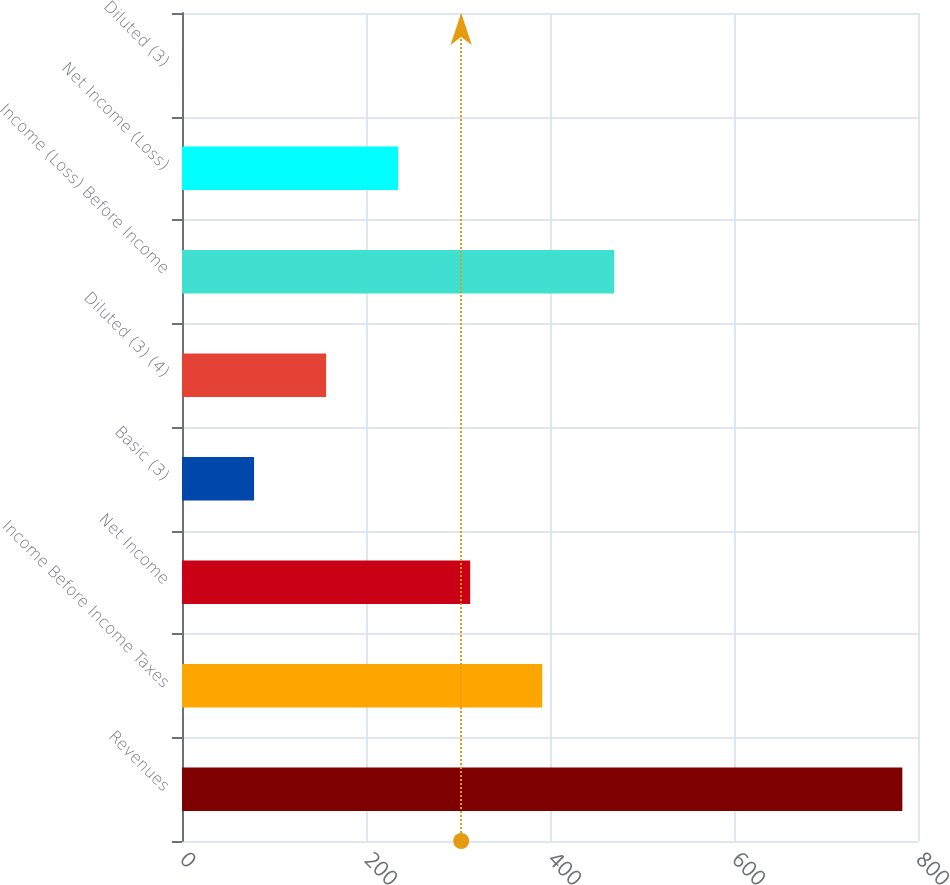Convert chart. <chart><loc_0><loc_0><loc_500><loc_500><bar_chart><fcel>Revenues<fcel>Income Before Income Taxes<fcel>Net Income<fcel>Basic (3)<fcel>Diluted (3) (4)<fcel>Income (Loss) Before Income<fcel>Net Income (Loss)<fcel>Diluted (3)<nl><fcel>783<fcel>391.55<fcel>313.25<fcel>78.35<fcel>156.65<fcel>469.85<fcel>234.95<fcel>0.05<nl></chart> 